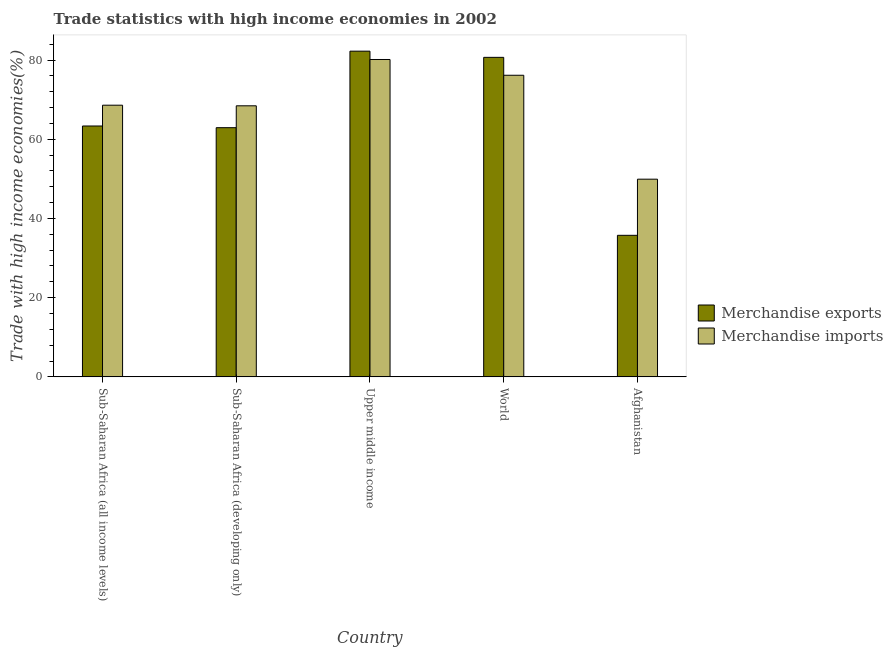How many different coloured bars are there?
Keep it short and to the point. 2. Are the number of bars per tick equal to the number of legend labels?
Provide a succinct answer. Yes. Are the number of bars on each tick of the X-axis equal?
Make the answer very short. Yes. How many bars are there on the 1st tick from the left?
Offer a very short reply. 2. How many bars are there on the 4th tick from the right?
Your response must be concise. 2. What is the label of the 1st group of bars from the left?
Ensure brevity in your answer.  Sub-Saharan Africa (all income levels). In how many cases, is the number of bars for a given country not equal to the number of legend labels?
Give a very brief answer. 0. What is the merchandise exports in World?
Offer a terse response. 80.68. Across all countries, what is the maximum merchandise imports?
Your answer should be very brief. 80.14. Across all countries, what is the minimum merchandise exports?
Offer a very short reply. 35.74. In which country was the merchandise imports maximum?
Your answer should be very brief. Upper middle income. In which country was the merchandise imports minimum?
Make the answer very short. Afghanistan. What is the total merchandise exports in the graph?
Offer a very short reply. 324.92. What is the difference between the merchandise exports in Sub-Saharan Africa (all income levels) and that in Upper middle income?
Provide a short and direct response. -18.89. What is the difference between the merchandise exports in Afghanistan and the merchandise imports in Sub-Saharan Africa (developing only)?
Your answer should be very brief. -32.7. What is the average merchandise imports per country?
Your response must be concise. 68.65. What is the difference between the merchandise imports and merchandise exports in Sub-Saharan Africa (all income levels)?
Offer a terse response. 5.25. In how many countries, is the merchandise exports greater than 68 %?
Ensure brevity in your answer.  2. What is the ratio of the merchandise exports in Afghanistan to that in Sub-Saharan Africa (all income levels)?
Keep it short and to the point. 0.56. Is the difference between the merchandise imports in Afghanistan and Upper middle income greater than the difference between the merchandise exports in Afghanistan and Upper middle income?
Provide a succinct answer. Yes. What is the difference between the highest and the second highest merchandise imports?
Your response must be concise. 3.98. What is the difference between the highest and the lowest merchandise imports?
Make the answer very short. 30.22. Is the sum of the merchandise imports in Sub-Saharan Africa (all income levels) and World greater than the maximum merchandise exports across all countries?
Your response must be concise. Yes. What does the 1st bar from the left in World represents?
Give a very brief answer. Merchandise exports. How many bars are there?
Your answer should be compact. 10. Are all the bars in the graph horizontal?
Your answer should be compact. No. Are the values on the major ticks of Y-axis written in scientific E-notation?
Provide a succinct answer. No. Does the graph contain any zero values?
Your answer should be compact. No. Where does the legend appear in the graph?
Offer a terse response. Center right. How are the legend labels stacked?
Your response must be concise. Vertical. What is the title of the graph?
Ensure brevity in your answer.  Trade statistics with high income economies in 2002. What is the label or title of the X-axis?
Offer a terse response. Country. What is the label or title of the Y-axis?
Provide a succinct answer. Trade with high income economies(%). What is the Trade with high income economies(%) of Merchandise exports in Sub-Saharan Africa (all income levels)?
Offer a very short reply. 63.35. What is the Trade with high income economies(%) in Merchandise imports in Sub-Saharan Africa (all income levels)?
Make the answer very short. 68.6. What is the Trade with high income economies(%) of Merchandise exports in Sub-Saharan Africa (developing only)?
Your answer should be compact. 62.92. What is the Trade with high income economies(%) in Merchandise imports in Sub-Saharan Africa (developing only)?
Keep it short and to the point. 68.44. What is the Trade with high income economies(%) in Merchandise exports in Upper middle income?
Your response must be concise. 82.24. What is the Trade with high income economies(%) in Merchandise imports in Upper middle income?
Offer a terse response. 80.14. What is the Trade with high income economies(%) of Merchandise exports in World?
Provide a short and direct response. 80.68. What is the Trade with high income economies(%) of Merchandise imports in World?
Your response must be concise. 76.16. What is the Trade with high income economies(%) of Merchandise exports in Afghanistan?
Make the answer very short. 35.74. What is the Trade with high income economies(%) of Merchandise imports in Afghanistan?
Provide a short and direct response. 49.91. Across all countries, what is the maximum Trade with high income economies(%) of Merchandise exports?
Offer a terse response. 82.24. Across all countries, what is the maximum Trade with high income economies(%) in Merchandise imports?
Provide a succinct answer. 80.14. Across all countries, what is the minimum Trade with high income economies(%) of Merchandise exports?
Your answer should be very brief. 35.74. Across all countries, what is the minimum Trade with high income economies(%) in Merchandise imports?
Keep it short and to the point. 49.91. What is the total Trade with high income economies(%) of Merchandise exports in the graph?
Give a very brief answer. 324.92. What is the total Trade with high income economies(%) of Merchandise imports in the graph?
Keep it short and to the point. 343.25. What is the difference between the Trade with high income economies(%) of Merchandise exports in Sub-Saharan Africa (all income levels) and that in Sub-Saharan Africa (developing only)?
Give a very brief answer. 0.43. What is the difference between the Trade with high income economies(%) of Merchandise imports in Sub-Saharan Africa (all income levels) and that in Sub-Saharan Africa (developing only)?
Ensure brevity in your answer.  0.15. What is the difference between the Trade with high income economies(%) of Merchandise exports in Sub-Saharan Africa (all income levels) and that in Upper middle income?
Make the answer very short. -18.89. What is the difference between the Trade with high income economies(%) of Merchandise imports in Sub-Saharan Africa (all income levels) and that in Upper middle income?
Make the answer very short. -11.54. What is the difference between the Trade with high income economies(%) of Merchandise exports in Sub-Saharan Africa (all income levels) and that in World?
Your answer should be very brief. -17.33. What is the difference between the Trade with high income economies(%) in Merchandise imports in Sub-Saharan Africa (all income levels) and that in World?
Provide a short and direct response. -7.56. What is the difference between the Trade with high income economies(%) of Merchandise exports in Sub-Saharan Africa (all income levels) and that in Afghanistan?
Provide a short and direct response. 27.61. What is the difference between the Trade with high income economies(%) of Merchandise imports in Sub-Saharan Africa (all income levels) and that in Afghanistan?
Make the answer very short. 18.68. What is the difference between the Trade with high income economies(%) in Merchandise exports in Sub-Saharan Africa (developing only) and that in Upper middle income?
Your response must be concise. -19.32. What is the difference between the Trade with high income economies(%) in Merchandise imports in Sub-Saharan Africa (developing only) and that in Upper middle income?
Provide a short and direct response. -11.69. What is the difference between the Trade with high income economies(%) of Merchandise exports in Sub-Saharan Africa (developing only) and that in World?
Provide a short and direct response. -17.76. What is the difference between the Trade with high income economies(%) of Merchandise imports in Sub-Saharan Africa (developing only) and that in World?
Make the answer very short. -7.71. What is the difference between the Trade with high income economies(%) of Merchandise exports in Sub-Saharan Africa (developing only) and that in Afghanistan?
Your answer should be compact. 27.18. What is the difference between the Trade with high income economies(%) of Merchandise imports in Sub-Saharan Africa (developing only) and that in Afghanistan?
Keep it short and to the point. 18.53. What is the difference between the Trade with high income economies(%) in Merchandise exports in Upper middle income and that in World?
Your answer should be compact. 1.56. What is the difference between the Trade with high income economies(%) in Merchandise imports in Upper middle income and that in World?
Your answer should be compact. 3.98. What is the difference between the Trade with high income economies(%) of Merchandise exports in Upper middle income and that in Afghanistan?
Your response must be concise. 46.5. What is the difference between the Trade with high income economies(%) of Merchandise imports in Upper middle income and that in Afghanistan?
Make the answer very short. 30.22. What is the difference between the Trade with high income economies(%) in Merchandise exports in World and that in Afghanistan?
Make the answer very short. 44.94. What is the difference between the Trade with high income economies(%) in Merchandise imports in World and that in Afghanistan?
Offer a terse response. 26.24. What is the difference between the Trade with high income economies(%) in Merchandise exports in Sub-Saharan Africa (all income levels) and the Trade with high income economies(%) in Merchandise imports in Sub-Saharan Africa (developing only)?
Your answer should be compact. -5.1. What is the difference between the Trade with high income economies(%) of Merchandise exports in Sub-Saharan Africa (all income levels) and the Trade with high income economies(%) of Merchandise imports in Upper middle income?
Offer a terse response. -16.79. What is the difference between the Trade with high income economies(%) of Merchandise exports in Sub-Saharan Africa (all income levels) and the Trade with high income economies(%) of Merchandise imports in World?
Offer a terse response. -12.81. What is the difference between the Trade with high income economies(%) of Merchandise exports in Sub-Saharan Africa (all income levels) and the Trade with high income economies(%) of Merchandise imports in Afghanistan?
Provide a short and direct response. 13.43. What is the difference between the Trade with high income economies(%) of Merchandise exports in Sub-Saharan Africa (developing only) and the Trade with high income economies(%) of Merchandise imports in Upper middle income?
Your response must be concise. -17.22. What is the difference between the Trade with high income economies(%) of Merchandise exports in Sub-Saharan Africa (developing only) and the Trade with high income economies(%) of Merchandise imports in World?
Ensure brevity in your answer.  -13.24. What is the difference between the Trade with high income economies(%) of Merchandise exports in Sub-Saharan Africa (developing only) and the Trade with high income economies(%) of Merchandise imports in Afghanistan?
Your response must be concise. 13. What is the difference between the Trade with high income economies(%) of Merchandise exports in Upper middle income and the Trade with high income economies(%) of Merchandise imports in World?
Your answer should be compact. 6.09. What is the difference between the Trade with high income economies(%) of Merchandise exports in Upper middle income and the Trade with high income economies(%) of Merchandise imports in Afghanistan?
Offer a terse response. 32.33. What is the difference between the Trade with high income economies(%) of Merchandise exports in World and the Trade with high income economies(%) of Merchandise imports in Afghanistan?
Your answer should be very brief. 30.76. What is the average Trade with high income economies(%) in Merchandise exports per country?
Give a very brief answer. 64.98. What is the average Trade with high income economies(%) of Merchandise imports per country?
Offer a very short reply. 68.65. What is the difference between the Trade with high income economies(%) in Merchandise exports and Trade with high income economies(%) in Merchandise imports in Sub-Saharan Africa (all income levels)?
Your answer should be compact. -5.25. What is the difference between the Trade with high income economies(%) in Merchandise exports and Trade with high income economies(%) in Merchandise imports in Sub-Saharan Africa (developing only)?
Make the answer very short. -5.53. What is the difference between the Trade with high income economies(%) of Merchandise exports and Trade with high income economies(%) of Merchandise imports in Upper middle income?
Your response must be concise. 2.1. What is the difference between the Trade with high income economies(%) in Merchandise exports and Trade with high income economies(%) in Merchandise imports in World?
Provide a short and direct response. 4.52. What is the difference between the Trade with high income economies(%) of Merchandise exports and Trade with high income economies(%) of Merchandise imports in Afghanistan?
Provide a succinct answer. -14.17. What is the ratio of the Trade with high income economies(%) of Merchandise exports in Sub-Saharan Africa (all income levels) to that in Sub-Saharan Africa (developing only)?
Offer a very short reply. 1.01. What is the ratio of the Trade with high income economies(%) in Merchandise imports in Sub-Saharan Africa (all income levels) to that in Sub-Saharan Africa (developing only)?
Offer a terse response. 1. What is the ratio of the Trade with high income economies(%) of Merchandise exports in Sub-Saharan Africa (all income levels) to that in Upper middle income?
Make the answer very short. 0.77. What is the ratio of the Trade with high income economies(%) of Merchandise imports in Sub-Saharan Africa (all income levels) to that in Upper middle income?
Your answer should be compact. 0.86. What is the ratio of the Trade with high income economies(%) in Merchandise exports in Sub-Saharan Africa (all income levels) to that in World?
Ensure brevity in your answer.  0.79. What is the ratio of the Trade with high income economies(%) of Merchandise imports in Sub-Saharan Africa (all income levels) to that in World?
Provide a succinct answer. 0.9. What is the ratio of the Trade with high income economies(%) of Merchandise exports in Sub-Saharan Africa (all income levels) to that in Afghanistan?
Provide a short and direct response. 1.77. What is the ratio of the Trade with high income economies(%) in Merchandise imports in Sub-Saharan Africa (all income levels) to that in Afghanistan?
Give a very brief answer. 1.37. What is the ratio of the Trade with high income economies(%) in Merchandise exports in Sub-Saharan Africa (developing only) to that in Upper middle income?
Make the answer very short. 0.77. What is the ratio of the Trade with high income economies(%) in Merchandise imports in Sub-Saharan Africa (developing only) to that in Upper middle income?
Provide a succinct answer. 0.85. What is the ratio of the Trade with high income economies(%) in Merchandise exports in Sub-Saharan Africa (developing only) to that in World?
Your answer should be very brief. 0.78. What is the ratio of the Trade with high income economies(%) of Merchandise imports in Sub-Saharan Africa (developing only) to that in World?
Offer a very short reply. 0.9. What is the ratio of the Trade with high income economies(%) of Merchandise exports in Sub-Saharan Africa (developing only) to that in Afghanistan?
Keep it short and to the point. 1.76. What is the ratio of the Trade with high income economies(%) of Merchandise imports in Sub-Saharan Africa (developing only) to that in Afghanistan?
Keep it short and to the point. 1.37. What is the ratio of the Trade with high income economies(%) of Merchandise exports in Upper middle income to that in World?
Provide a succinct answer. 1.02. What is the ratio of the Trade with high income economies(%) of Merchandise imports in Upper middle income to that in World?
Offer a very short reply. 1.05. What is the ratio of the Trade with high income economies(%) in Merchandise exports in Upper middle income to that in Afghanistan?
Keep it short and to the point. 2.3. What is the ratio of the Trade with high income economies(%) of Merchandise imports in Upper middle income to that in Afghanistan?
Offer a terse response. 1.61. What is the ratio of the Trade with high income economies(%) of Merchandise exports in World to that in Afghanistan?
Offer a terse response. 2.26. What is the ratio of the Trade with high income economies(%) of Merchandise imports in World to that in Afghanistan?
Provide a short and direct response. 1.53. What is the difference between the highest and the second highest Trade with high income economies(%) of Merchandise exports?
Your response must be concise. 1.56. What is the difference between the highest and the second highest Trade with high income economies(%) in Merchandise imports?
Give a very brief answer. 3.98. What is the difference between the highest and the lowest Trade with high income economies(%) of Merchandise exports?
Your answer should be very brief. 46.5. What is the difference between the highest and the lowest Trade with high income economies(%) in Merchandise imports?
Make the answer very short. 30.22. 